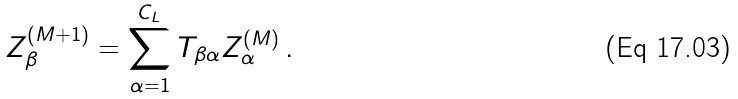Convert formula to latex. <formula><loc_0><loc_0><loc_500><loc_500>Z ^ { ( M + 1 ) } _ { \beta } = \sum _ { \alpha = 1 } ^ { C _ { L } } T _ { \beta \alpha } Z ^ { ( M ) } _ { \alpha } \, .</formula> 